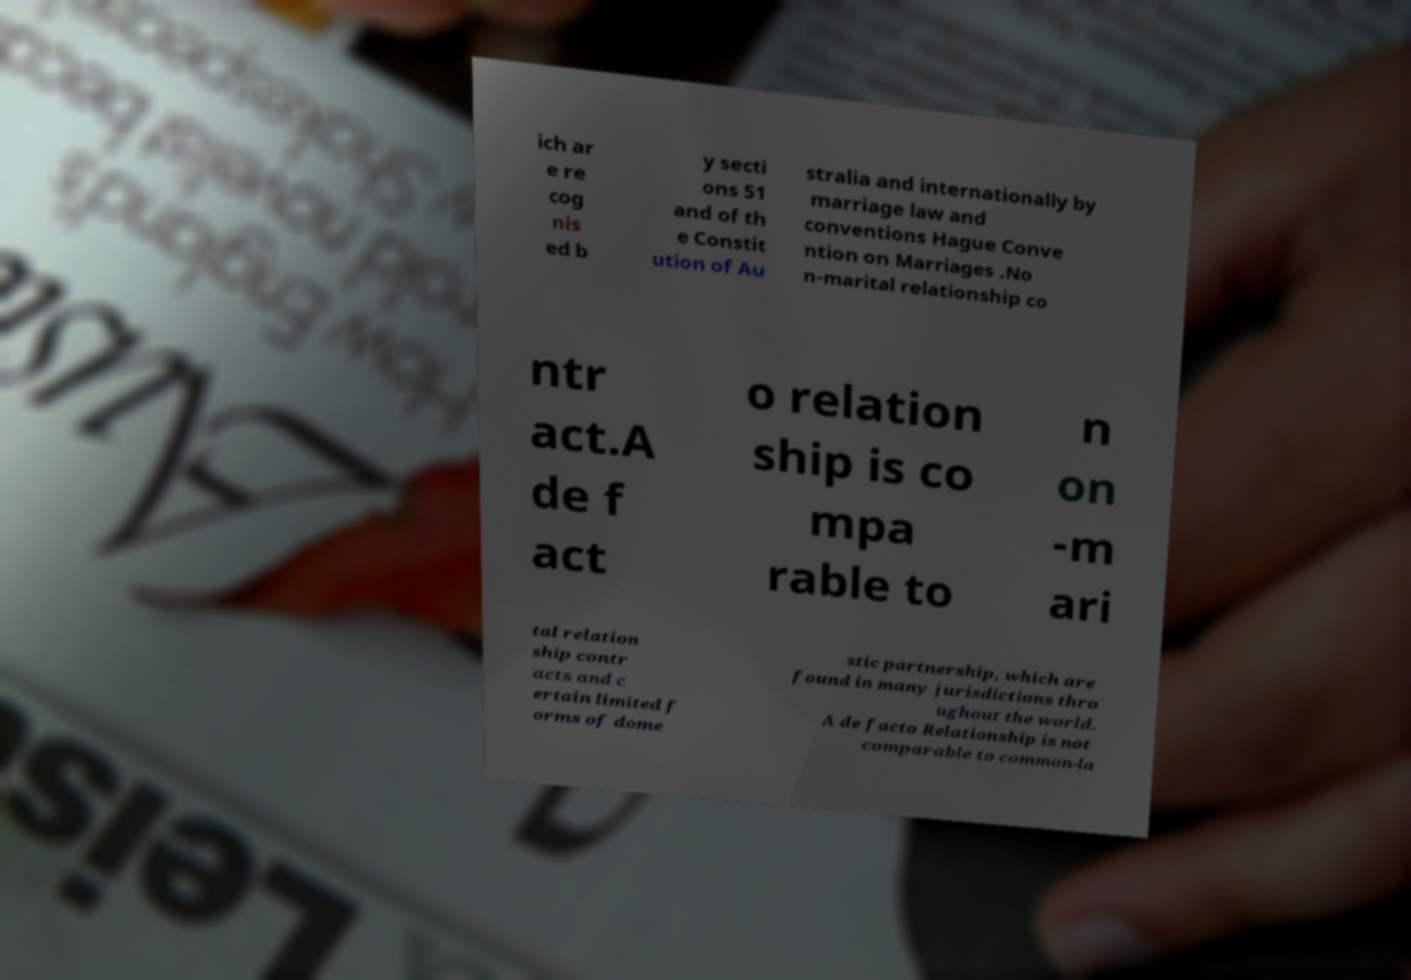There's text embedded in this image that I need extracted. Can you transcribe it verbatim? ich ar e re cog nis ed b y secti ons 51 and of th e Constit ution of Au stralia and internationally by marriage law and conventions Hague Conve ntion on Marriages .No n-marital relationship co ntr act.A de f act o relation ship is co mpa rable to n on -m ari tal relation ship contr acts and c ertain limited f orms of dome stic partnership, which are found in many jurisdictions thro ughout the world. A de facto Relationship is not comparable to common-la 